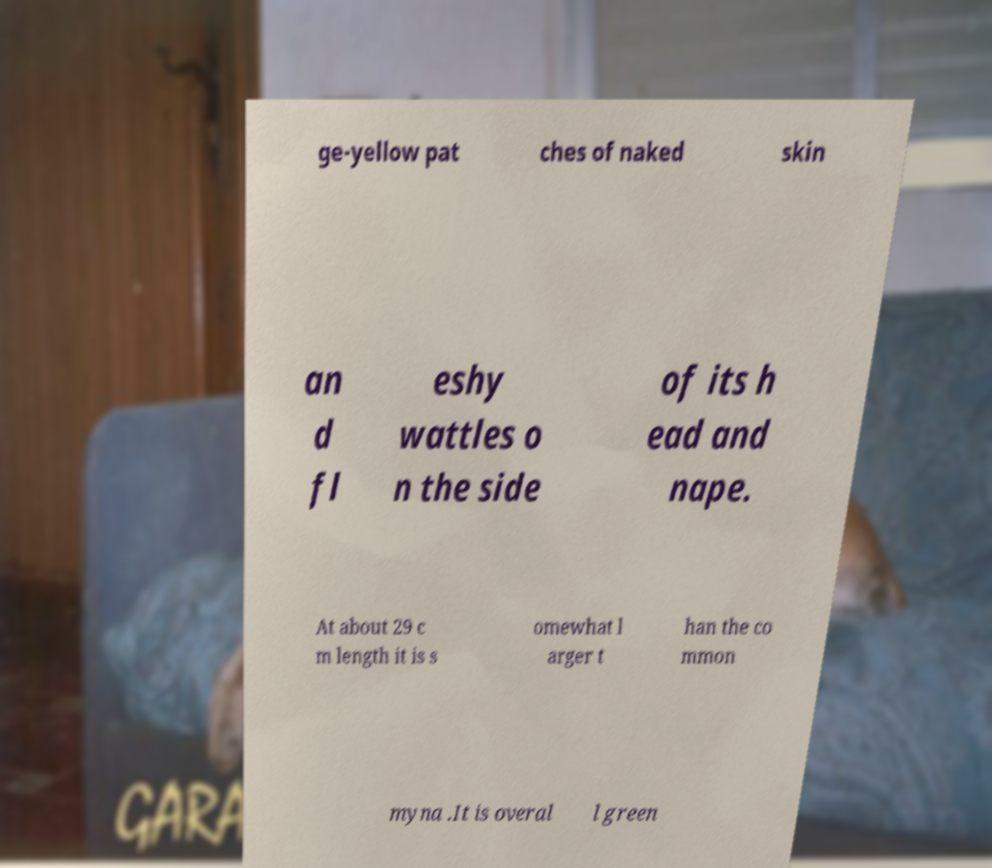Can you read and provide the text displayed in the image?This photo seems to have some interesting text. Can you extract and type it out for me? ge-yellow pat ches of naked skin an d fl eshy wattles o n the side of its h ead and nape. At about 29 c m length it is s omewhat l arger t han the co mmon myna .It is overal l green 